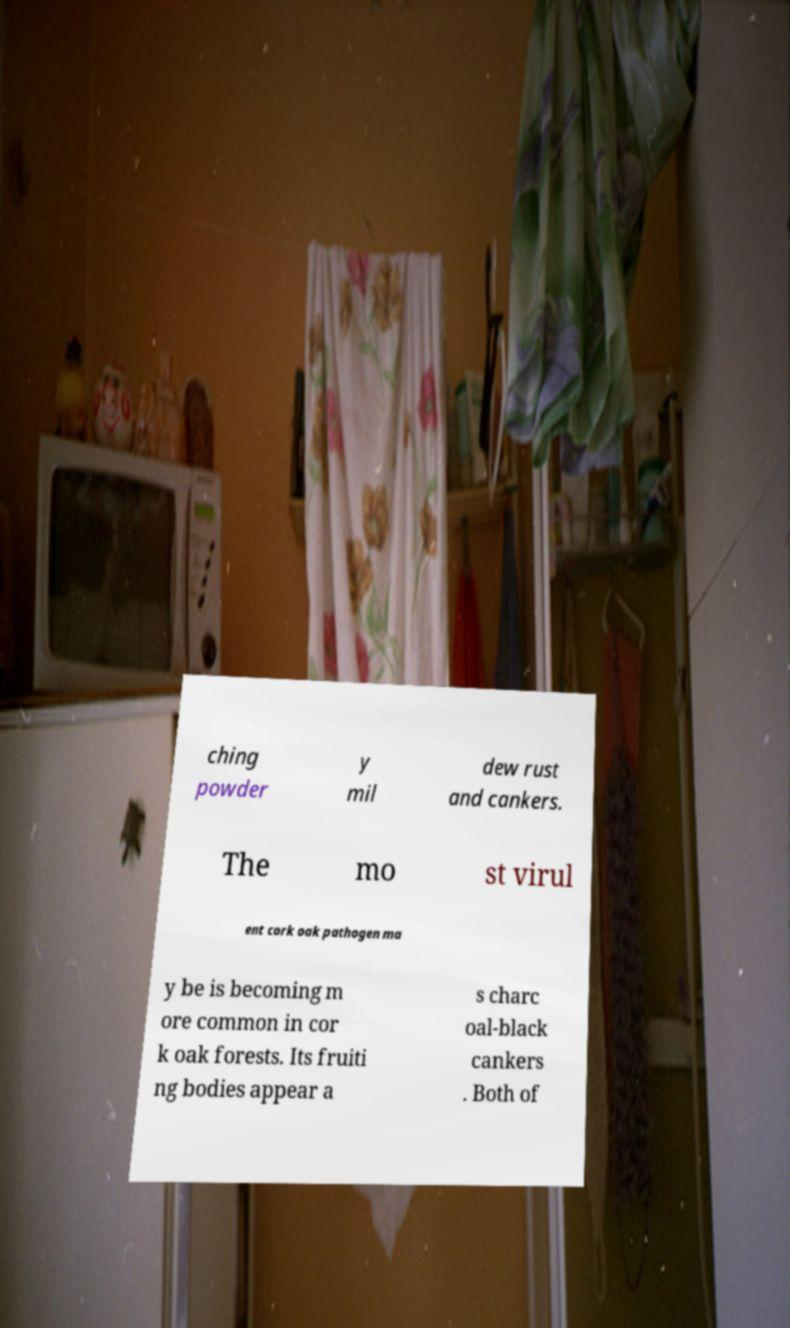For documentation purposes, I need the text within this image transcribed. Could you provide that? ching powder y mil dew rust and cankers. The mo st virul ent cork oak pathogen ma y be is becoming m ore common in cor k oak forests. Its fruiti ng bodies appear a s charc oal-black cankers . Both of 